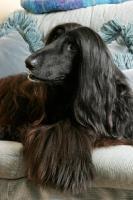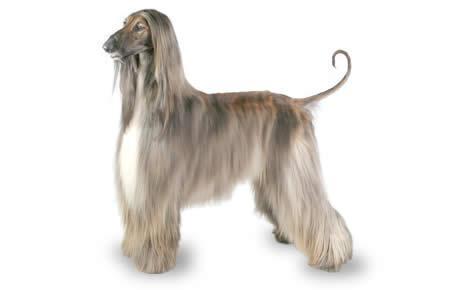The first image is the image on the left, the second image is the image on the right. Given the left and right images, does the statement "An image shows a dark-haired hound lounging on furniture with throw pillows." hold true? Answer yes or no. Yes. The first image is the image on the left, the second image is the image on the right. Assess this claim about the two images: "At least one dog in one of the images is outside on a sunny day.". Correct or not? Answer yes or no. No. 